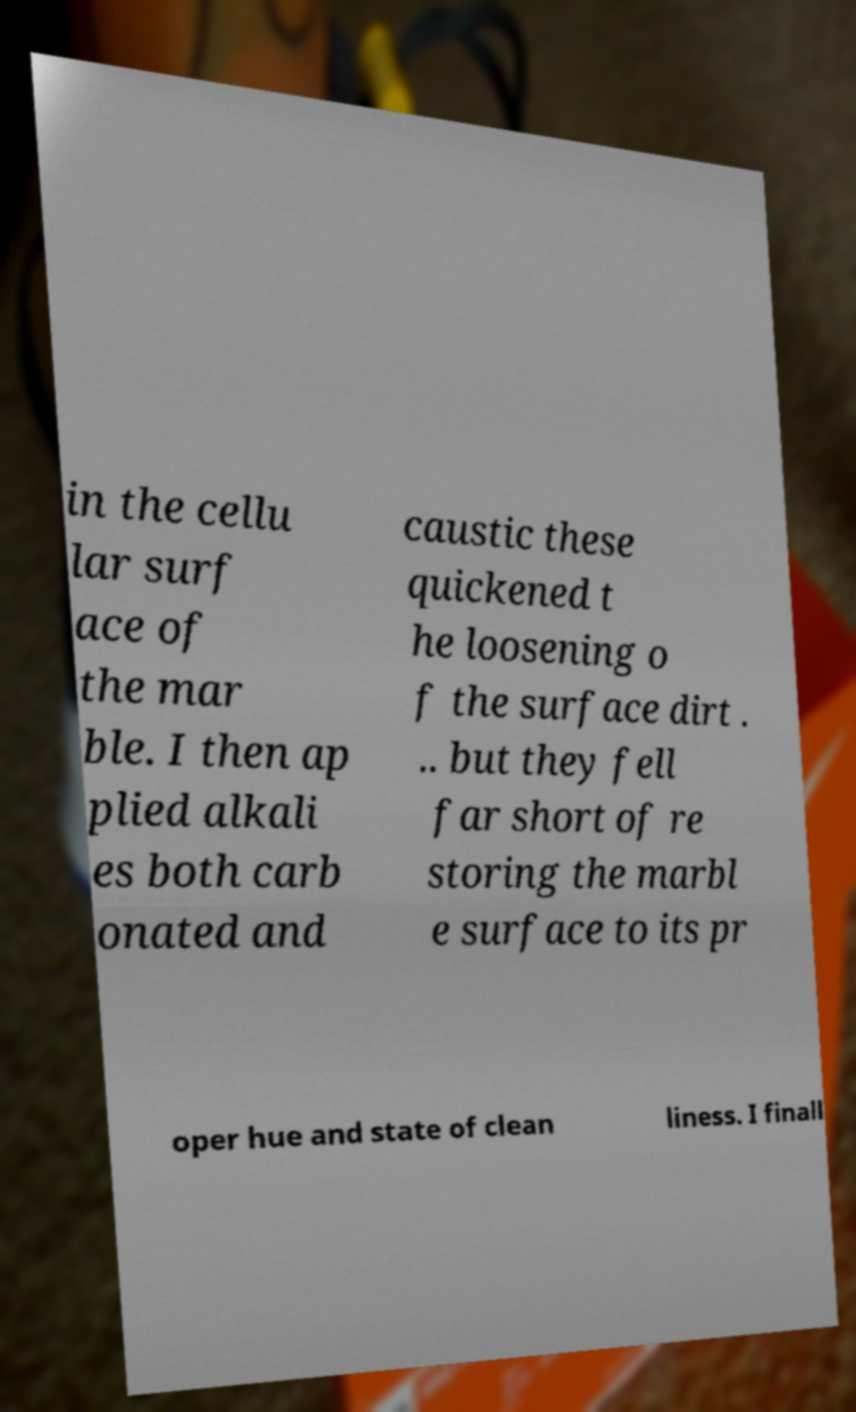For documentation purposes, I need the text within this image transcribed. Could you provide that? in the cellu lar surf ace of the mar ble. I then ap plied alkali es both carb onated and caustic these quickened t he loosening o f the surface dirt . .. but they fell far short of re storing the marbl e surface to its pr oper hue and state of clean liness. I finall 